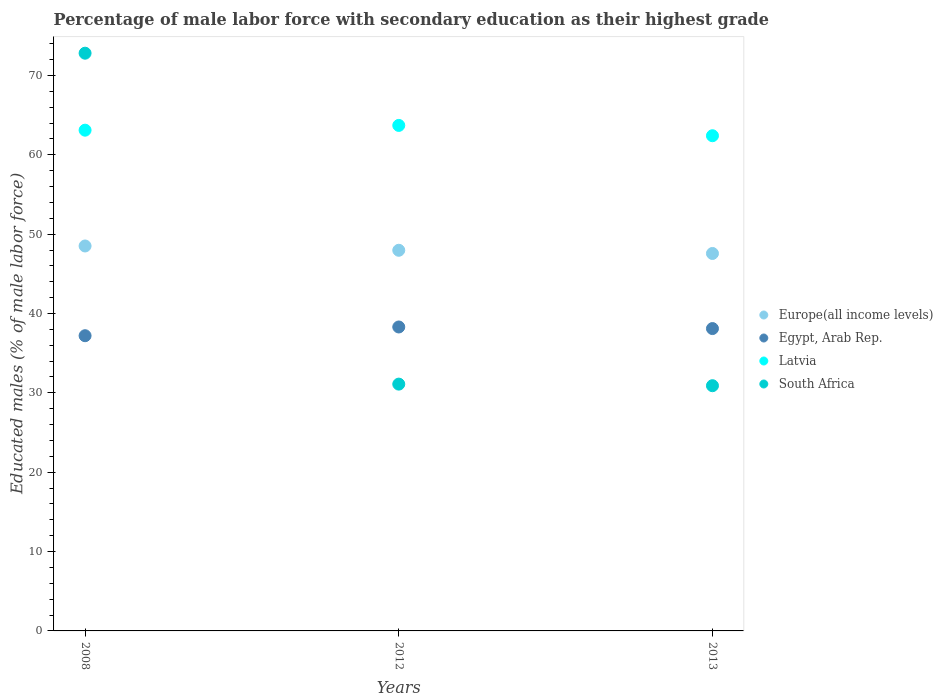Is the number of dotlines equal to the number of legend labels?
Make the answer very short. Yes. What is the percentage of male labor force with secondary education in Egypt, Arab Rep. in 2013?
Ensure brevity in your answer.  38.1. Across all years, what is the maximum percentage of male labor force with secondary education in Europe(all income levels)?
Your answer should be compact. 48.51. Across all years, what is the minimum percentage of male labor force with secondary education in South Africa?
Your answer should be compact. 30.9. In which year was the percentage of male labor force with secondary education in Latvia minimum?
Make the answer very short. 2013. What is the total percentage of male labor force with secondary education in South Africa in the graph?
Offer a very short reply. 134.8. What is the difference between the percentage of male labor force with secondary education in South Africa in 2012 and that in 2013?
Give a very brief answer. 0.2. What is the difference between the percentage of male labor force with secondary education in South Africa in 2013 and the percentage of male labor force with secondary education in Europe(all income levels) in 2008?
Ensure brevity in your answer.  -17.61. What is the average percentage of male labor force with secondary education in South Africa per year?
Your answer should be compact. 44.93. In the year 2012, what is the difference between the percentage of male labor force with secondary education in Egypt, Arab Rep. and percentage of male labor force with secondary education in South Africa?
Your answer should be compact. 7.2. What is the ratio of the percentage of male labor force with secondary education in Latvia in 2008 to that in 2013?
Provide a short and direct response. 1.01. What is the difference between the highest and the second highest percentage of male labor force with secondary education in Latvia?
Your response must be concise. 0.6. What is the difference between the highest and the lowest percentage of male labor force with secondary education in South Africa?
Offer a very short reply. 41.9. Is it the case that in every year, the sum of the percentage of male labor force with secondary education in Europe(all income levels) and percentage of male labor force with secondary education in South Africa  is greater than the sum of percentage of male labor force with secondary education in Egypt, Arab Rep. and percentage of male labor force with secondary education in Latvia?
Keep it short and to the point. Yes. Is the percentage of male labor force with secondary education in Egypt, Arab Rep. strictly greater than the percentage of male labor force with secondary education in Latvia over the years?
Your answer should be compact. No. Is the percentage of male labor force with secondary education in South Africa strictly less than the percentage of male labor force with secondary education in Egypt, Arab Rep. over the years?
Your answer should be compact. No. Are the values on the major ticks of Y-axis written in scientific E-notation?
Provide a succinct answer. No. Does the graph contain any zero values?
Your response must be concise. No. Does the graph contain grids?
Provide a succinct answer. No. Where does the legend appear in the graph?
Keep it short and to the point. Center right. How are the legend labels stacked?
Your answer should be very brief. Vertical. What is the title of the graph?
Provide a succinct answer. Percentage of male labor force with secondary education as their highest grade. Does "Brunei Darussalam" appear as one of the legend labels in the graph?
Offer a terse response. No. What is the label or title of the X-axis?
Offer a terse response. Years. What is the label or title of the Y-axis?
Offer a terse response. Educated males (% of male labor force). What is the Educated males (% of male labor force) in Europe(all income levels) in 2008?
Your response must be concise. 48.51. What is the Educated males (% of male labor force) of Egypt, Arab Rep. in 2008?
Provide a short and direct response. 37.2. What is the Educated males (% of male labor force) in Latvia in 2008?
Keep it short and to the point. 63.1. What is the Educated males (% of male labor force) of South Africa in 2008?
Make the answer very short. 72.8. What is the Educated males (% of male labor force) in Europe(all income levels) in 2012?
Offer a terse response. 47.97. What is the Educated males (% of male labor force) of Egypt, Arab Rep. in 2012?
Offer a terse response. 38.3. What is the Educated males (% of male labor force) in Latvia in 2012?
Offer a terse response. 63.7. What is the Educated males (% of male labor force) in South Africa in 2012?
Offer a terse response. 31.1. What is the Educated males (% of male labor force) of Europe(all income levels) in 2013?
Make the answer very short. 47.56. What is the Educated males (% of male labor force) in Egypt, Arab Rep. in 2013?
Give a very brief answer. 38.1. What is the Educated males (% of male labor force) of Latvia in 2013?
Provide a short and direct response. 62.4. What is the Educated males (% of male labor force) of South Africa in 2013?
Your answer should be very brief. 30.9. Across all years, what is the maximum Educated males (% of male labor force) of Europe(all income levels)?
Give a very brief answer. 48.51. Across all years, what is the maximum Educated males (% of male labor force) in Egypt, Arab Rep.?
Offer a terse response. 38.3. Across all years, what is the maximum Educated males (% of male labor force) of Latvia?
Make the answer very short. 63.7. Across all years, what is the maximum Educated males (% of male labor force) of South Africa?
Offer a terse response. 72.8. Across all years, what is the minimum Educated males (% of male labor force) in Europe(all income levels)?
Make the answer very short. 47.56. Across all years, what is the minimum Educated males (% of male labor force) of Egypt, Arab Rep.?
Offer a terse response. 37.2. Across all years, what is the minimum Educated males (% of male labor force) in Latvia?
Offer a terse response. 62.4. Across all years, what is the minimum Educated males (% of male labor force) in South Africa?
Make the answer very short. 30.9. What is the total Educated males (% of male labor force) of Europe(all income levels) in the graph?
Provide a succinct answer. 144.04. What is the total Educated males (% of male labor force) of Egypt, Arab Rep. in the graph?
Ensure brevity in your answer.  113.6. What is the total Educated males (% of male labor force) of Latvia in the graph?
Offer a very short reply. 189.2. What is the total Educated males (% of male labor force) of South Africa in the graph?
Your response must be concise. 134.8. What is the difference between the Educated males (% of male labor force) of Europe(all income levels) in 2008 and that in 2012?
Your answer should be very brief. 0.54. What is the difference between the Educated males (% of male labor force) of Egypt, Arab Rep. in 2008 and that in 2012?
Keep it short and to the point. -1.1. What is the difference between the Educated males (% of male labor force) of South Africa in 2008 and that in 2012?
Offer a terse response. 41.7. What is the difference between the Educated males (% of male labor force) in Europe(all income levels) in 2008 and that in 2013?
Offer a terse response. 0.94. What is the difference between the Educated males (% of male labor force) in Egypt, Arab Rep. in 2008 and that in 2013?
Your answer should be very brief. -0.9. What is the difference between the Educated males (% of male labor force) in Latvia in 2008 and that in 2013?
Ensure brevity in your answer.  0.7. What is the difference between the Educated males (% of male labor force) in South Africa in 2008 and that in 2013?
Make the answer very short. 41.9. What is the difference between the Educated males (% of male labor force) of Europe(all income levels) in 2012 and that in 2013?
Your response must be concise. 0.4. What is the difference between the Educated males (% of male labor force) in Egypt, Arab Rep. in 2012 and that in 2013?
Make the answer very short. 0.2. What is the difference between the Educated males (% of male labor force) of Europe(all income levels) in 2008 and the Educated males (% of male labor force) of Egypt, Arab Rep. in 2012?
Give a very brief answer. 10.21. What is the difference between the Educated males (% of male labor force) of Europe(all income levels) in 2008 and the Educated males (% of male labor force) of Latvia in 2012?
Provide a succinct answer. -15.19. What is the difference between the Educated males (% of male labor force) of Europe(all income levels) in 2008 and the Educated males (% of male labor force) of South Africa in 2012?
Your answer should be very brief. 17.41. What is the difference between the Educated males (% of male labor force) in Egypt, Arab Rep. in 2008 and the Educated males (% of male labor force) in Latvia in 2012?
Provide a succinct answer. -26.5. What is the difference between the Educated males (% of male labor force) of Egypt, Arab Rep. in 2008 and the Educated males (% of male labor force) of South Africa in 2012?
Your response must be concise. 6.1. What is the difference between the Educated males (% of male labor force) in Europe(all income levels) in 2008 and the Educated males (% of male labor force) in Egypt, Arab Rep. in 2013?
Keep it short and to the point. 10.41. What is the difference between the Educated males (% of male labor force) of Europe(all income levels) in 2008 and the Educated males (% of male labor force) of Latvia in 2013?
Offer a very short reply. -13.89. What is the difference between the Educated males (% of male labor force) of Europe(all income levels) in 2008 and the Educated males (% of male labor force) of South Africa in 2013?
Your answer should be compact. 17.61. What is the difference between the Educated males (% of male labor force) in Egypt, Arab Rep. in 2008 and the Educated males (% of male labor force) in Latvia in 2013?
Provide a succinct answer. -25.2. What is the difference between the Educated males (% of male labor force) of Latvia in 2008 and the Educated males (% of male labor force) of South Africa in 2013?
Your response must be concise. 32.2. What is the difference between the Educated males (% of male labor force) in Europe(all income levels) in 2012 and the Educated males (% of male labor force) in Egypt, Arab Rep. in 2013?
Provide a succinct answer. 9.87. What is the difference between the Educated males (% of male labor force) in Europe(all income levels) in 2012 and the Educated males (% of male labor force) in Latvia in 2013?
Offer a terse response. -14.43. What is the difference between the Educated males (% of male labor force) in Europe(all income levels) in 2012 and the Educated males (% of male labor force) in South Africa in 2013?
Keep it short and to the point. 17.07. What is the difference between the Educated males (% of male labor force) in Egypt, Arab Rep. in 2012 and the Educated males (% of male labor force) in Latvia in 2013?
Keep it short and to the point. -24.1. What is the difference between the Educated males (% of male labor force) of Latvia in 2012 and the Educated males (% of male labor force) of South Africa in 2013?
Keep it short and to the point. 32.8. What is the average Educated males (% of male labor force) of Europe(all income levels) per year?
Keep it short and to the point. 48.01. What is the average Educated males (% of male labor force) of Egypt, Arab Rep. per year?
Your answer should be compact. 37.87. What is the average Educated males (% of male labor force) of Latvia per year?
Give a very brief answer. 63.07. What is the average Educated males (% of male labor force) of South Africa per year?
Your response must be concise. 44.93. In the year 2008, what is the difference between the Educated males (% of male labor force) in Europe(all income levels) and Educated males (% of male labor force) in Egypt, Arab Rep.?
Ensure brevity in your answer.  11.31. In the year 2008, what is the difference between the Educated males (% of male labor force) in Europe(all income levels) and Educated males (% of male labor force) in Latvia?
Provide a short and direct response. -14.59. In the year 2008, what is the difference between the Educated males (% of male labor force) of Europe(all income levels) and Educated males (% of male labor force) of South Africa?
Ensure brevity in your answer.  -24.29. In the year 2008, what is the difference between the Educated males (% of male labor force) in Egypt, Arab Rep. and Educated males (% of male labor force) in Latvia?
Your answer should be very brief. -25.9. In the year 2008, what is the difference between the Educated males (% of male labor force) in Egypt, Arab Rep. and Educated males (% of male labor force) in South Africa?
Offer a very short reply. -35.6. In the year 2008, what is the difference between the Educated males (% of male labor force) in Latvia and Educated males (% of male labor force) in South Africa?
Offer a very short reply. -9.7. In the year 2012, what is the difference between the Educated males (% of male labor force) in Europe(all income levels) and Educated males (% of male labor force) in Egypt, Arab Rep.?
Give a very brief answer. 9.67. In the year 2012, what is the difference between the Educated males (% of male labor force) of Europe(all income levels) and Educated males (% of male labor force) of Latvia?
Offer a terse response. -15.73. In the year 2012, what is the difference between the Educated males (% of male labor force) of Europe(all income levels) and Educated males (% of male labor force) of South Africa?
Your response must be concise. 16.87. In the year 2012, what is the difference between the Educated males (% of male labor force) of Egypt, Arab Rep. and Educated males (% of male labor force) of Latvia?
Offer a very short reply. -25.4. In the year 2012, what is the difference between the Educated males (% of male labor force) of Egypt, Arab Rep. and Educated males (% of male labor force) of South Africa?
Make the answer very short. 7.2. In the year 2012, what is the difference between the Educated males (% of male labor force) of Latvia and Educated males (% of male labor force) of South Africa?
Ensure brevity in your answer.  32.6. In the year 2013, what is the difference between the Educated males (% of male labor force) in Europe(all income levels) and Educated males (% of male labor force) in Egypt, Arab Rep.?
Ensure brevity in your answer.  9.46. In the year 2013, what is the difference between the Educated males (% of male labor force) in Europe(all income levels) and Educated males (% of male labor force) in Latvia?
Your response must be concise. -14.84. In the year 2013, what is the difference between the Educated males (% of male labor force) in Europe(all income levels) and Educated males (% of male labor force) in South Africa?
Keep it short and to the point. 16.66. In the year 2013, what is the difference between the Educated males (% of male labor force) in Egypt, Arab Rep. and Educated males (% of male labor force) in Latvia?
Your response must be concise. -24.3. In the year 2013, what is the difference between the Educated males (% of male labor force) of Egypt, Arab Rep. and Educated males (% of male labor force) of South Africa?
Provide a succinct answer. 7.2. In the year 2013, what is the difference between the Educated males (% of male labor force) of Latvia and Educated males (% of male labor force) of South Africa?
Keep it short and to the point. 31.5. What is the ratio of the Educated males (% of male labor force) of Europe(all income levels) in 2008 to that in 2012?
Make the answer very short. 1.01. What is the ratio of the Educated males (% of male labor force) of Egypt, Arab Rep. in 2008 to that in 2012?
Keep it short and to the point. 0.97. What is the ratio of the Educated males (% of male labor force) in Latvia in 2008 to that in 2012?
Offer a terse response. 0.99. What is the ratio of the Educated males (% of male labor force) of South Africa in 2008 to that in 2012?
Offer a terse response. 2.34. What is the ratio of the Educated males (% of male labor force) in Europe(all income levels) in 2008 to that in 2013?
Provide a succinct answer. 1.02. What is the ratio of the Educated males (% of male labor force) in Egypt, Arab Rep. in 2008 to that in 2013?
Make the answer very short. 0.98. What is the ratio of the Educated males (% of male labor force) in Latvia in 2008 to that in 2013?
Ensure brevity in your answer.  1.01. What is the ratio of the Educated males (% of male labor force) in South Africa in 2008 to that in 2013?
Offer a terse response. 2.36. What is the ratio of the Educated males (% of male labor force) in Europe(all income levels) in 2012 to that in 2013?
Provide a short and direct response. 1.01. What is the ratio of the Educated males (% of male labor force) in Egypt, Arab Rep. in 2012 to that in 2013?
Provide a short and direct response. 1.01. What is the ratio of the Educated males (% of male labor force) in Latvia in 2012 to that in 2013?
Your answer should be compact. 1.02. What is the ratio of the Educated males (% of male labor force) in South Africa in 2012 to that in 2013?
Keep it short and to the point. 1.01. What is the difference between the highest and the second highest Educated males (% of male labor force) of Europe(all income levels)?
Give a very brief answer. 0.54. What is the difference between the highest and the second highest Educated males (% of male labor force) in South Africa?
Ensure brevity in your answer.  41.7. What is the difference between the highest and the lowest Educated males (% of male labor force) of Europe(all income levels)?
Offer a very short reply. 0.94. What is the difference between the highest and the lowest Educated males (% of male labor force) of South Africa?
Offer a terse response. 41.9. 